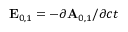<formula> <loc_0><loc_0><loc_500><loc_500>E _ { 0 , 1 } = - \partial A _ { 0 , 1 } / \partial c t</formula> 